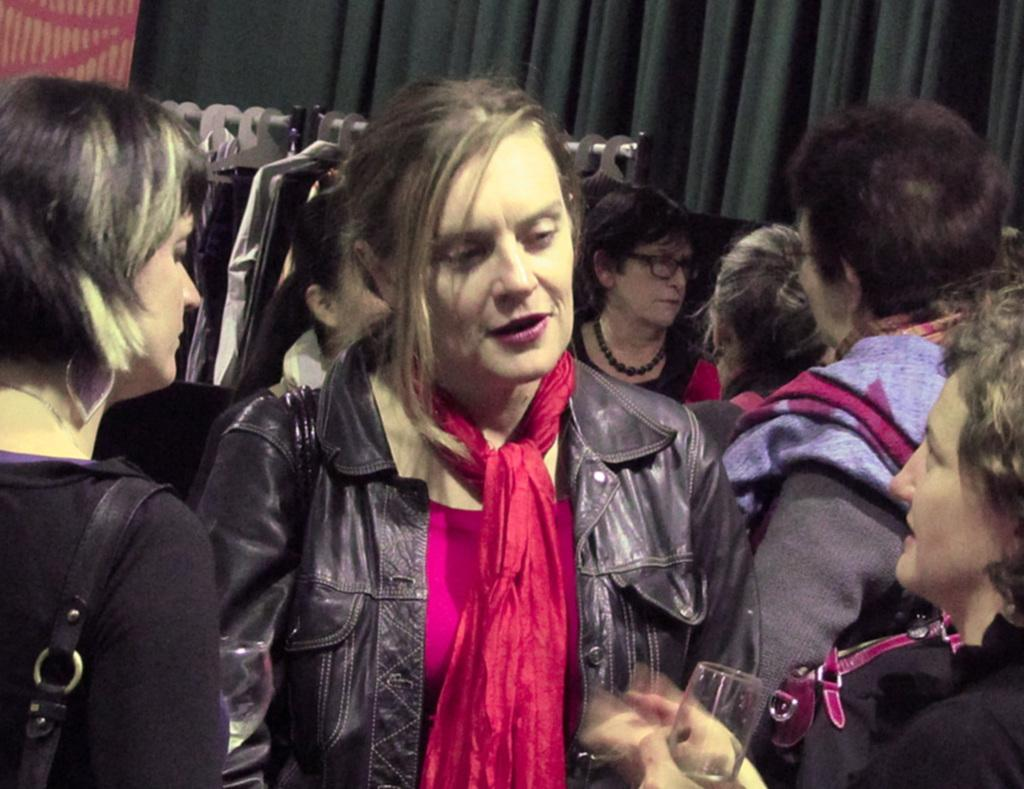What is the main focus of the image? The main focus of the image is the people in the center. What can be seen in the background of the image? There is a curtain in the background of the image. What else is present in the image besides the people and curtain? There are clothes on a rack. What type of ear is visible on the person in the image? There is no ear visible on the person in the image. How many hands are holding scissors in the image? There are no scissors or hands holding scissors present in the image. 